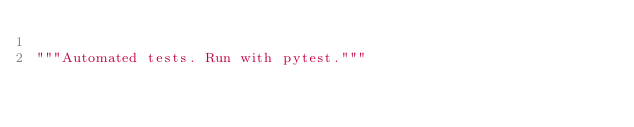<code> <loc_0><loc_0><loc_500><loc_500><_Python_>
"""Automated tests. Run with pytest."""
</code> 